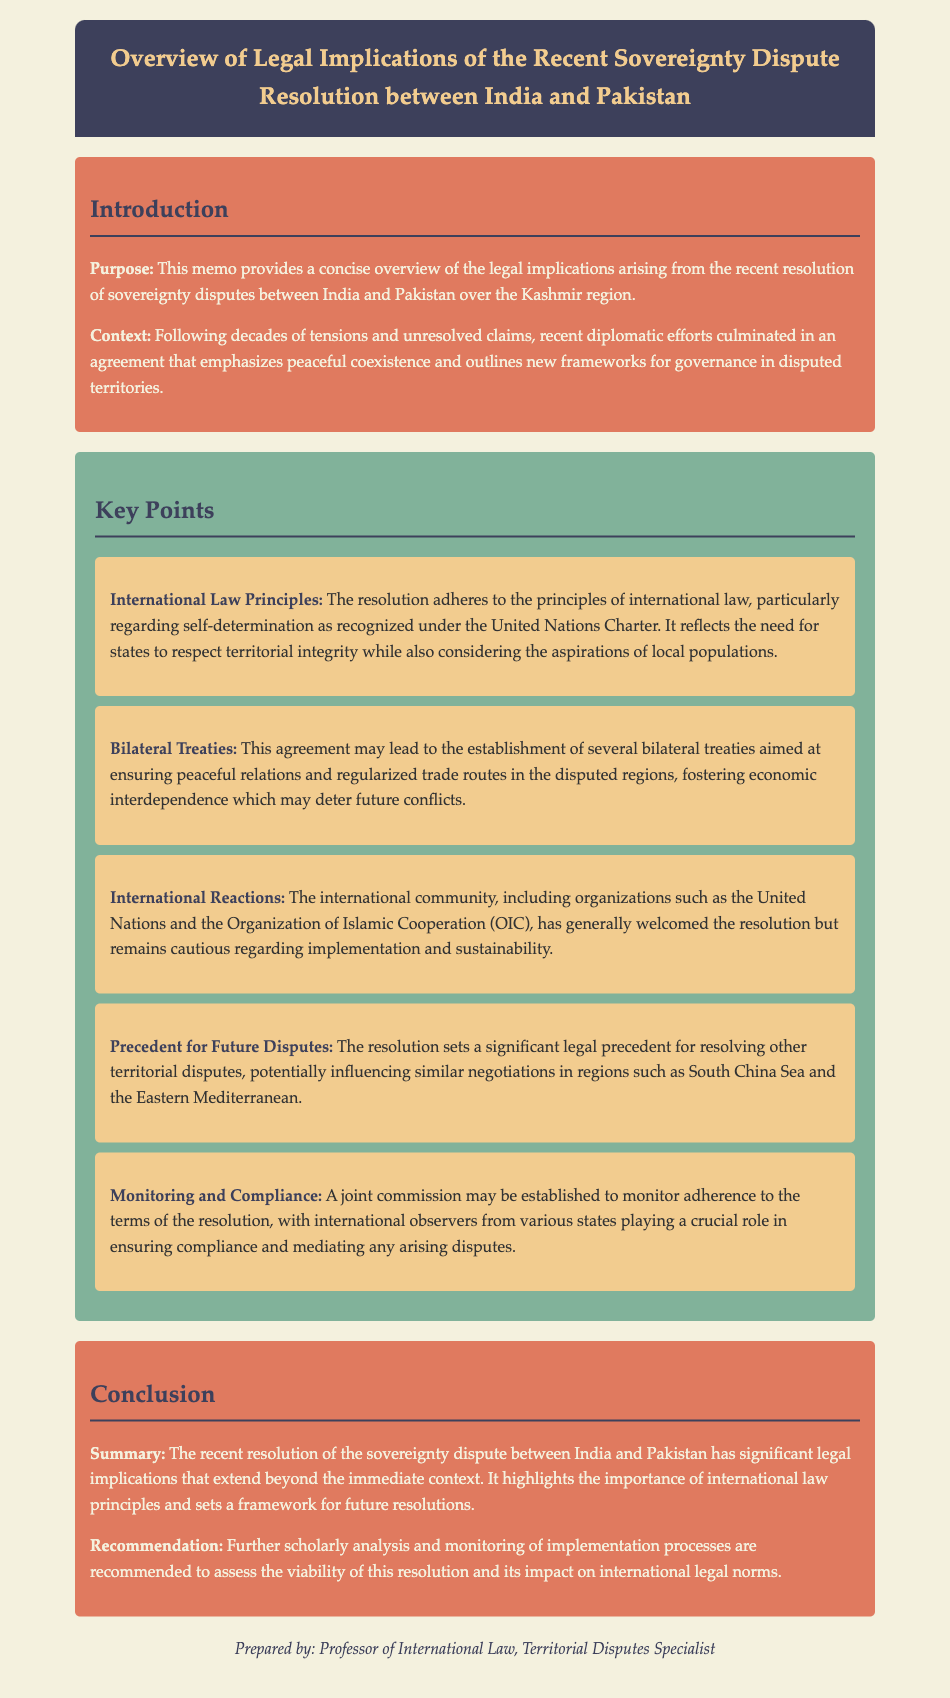What is the purpose of the memo? The purpose of the memo is to provide a concise overview of the legal implications arising from the recent resolution of sovereignty disputes between India and Pakistan over the Kashmir region.
Answer: To provide a concise overview of the legal implications What region is the sovereignty dispute about? The memo states that the sovereignty dispute is over the Kashmir region.
Answer: Kashmir What principle of international law is emphasized in the resolution? The resolution emphasizes the principle of self-determination as recognized under the United Nations Charter.
Answer: Self-determination What organization has welcomed the resolution but is cautious about implementation? The international community, including organizations such as the United Nations, has welcomed the resolution but remains cautious regarding implementation.
Answer: United Nations What may be established to monitor adherence to the resolution? A joint commission may be established to monitor adherence to the terms of the resolution.
Answer: Joint commission How does the resolution affect future territorial disputes? The resolution sets a significant legal precedent for resolving other territorial disputes.
Answer: Sets a significant legal precedent What does the memo recommend for future assessment? The memo recommends further scholarly analysis and monitoring of implementation processes to assess the viability of the resolution.
Answer: Further scholarly analysis and monitoring What is the date of the memo? The memo does not provide a specific date.
Answer: Not specified 